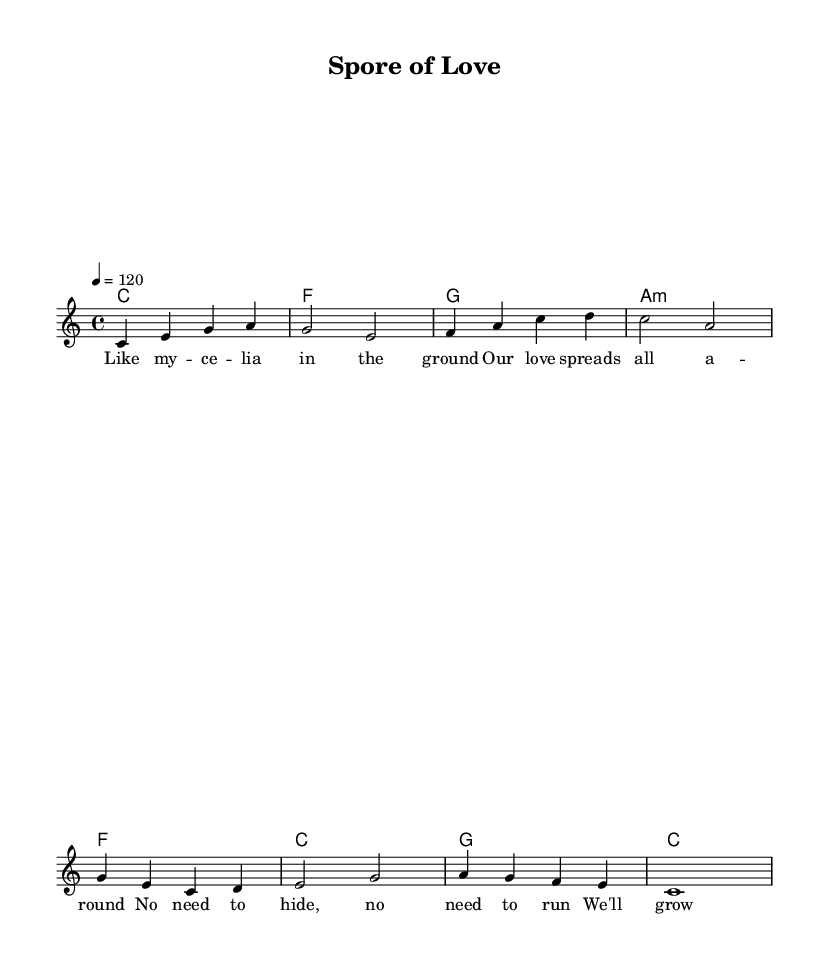What is the key signature of this music? The key signature is indicated at the beginning of the score. In this case, it shows no sharps or flats, indicating the piece is in C major.
Answer: C major What is the time signature of this music? The time signature is shown at the beginning of the score, indicated by the "4/4" marking. This means there are four beats in a measure, and the quarter note gets one beat.
Answer: 4/4 What is the tempo marking of this music? The tempo marking is provided in beats per minute near the beginning of the score. It is written as "4 = 120," meaning there are 120 beats per minute.
Answer: 120 How many measures are in the verse section? To determine the number of measures in the verse section, we look at the lyric section in the score. Counting the lines and checking for the end of each measure, we find there are four measures in the verse.
Answer: 4 What metaphor is used in the chorus related to fungi? The chorus refers to "fungi in symbiosis," which is a biological relationship between fungi and other organisms. This metaphor suggests a close and harmonious relationship.
Answer: fungi in symbiosis Which chord follows the first line of the verse? In the score, the verse lyrics are aligned with the chord symbols directly above them. The first line of the verse starts with the chord C.
Answer: C 